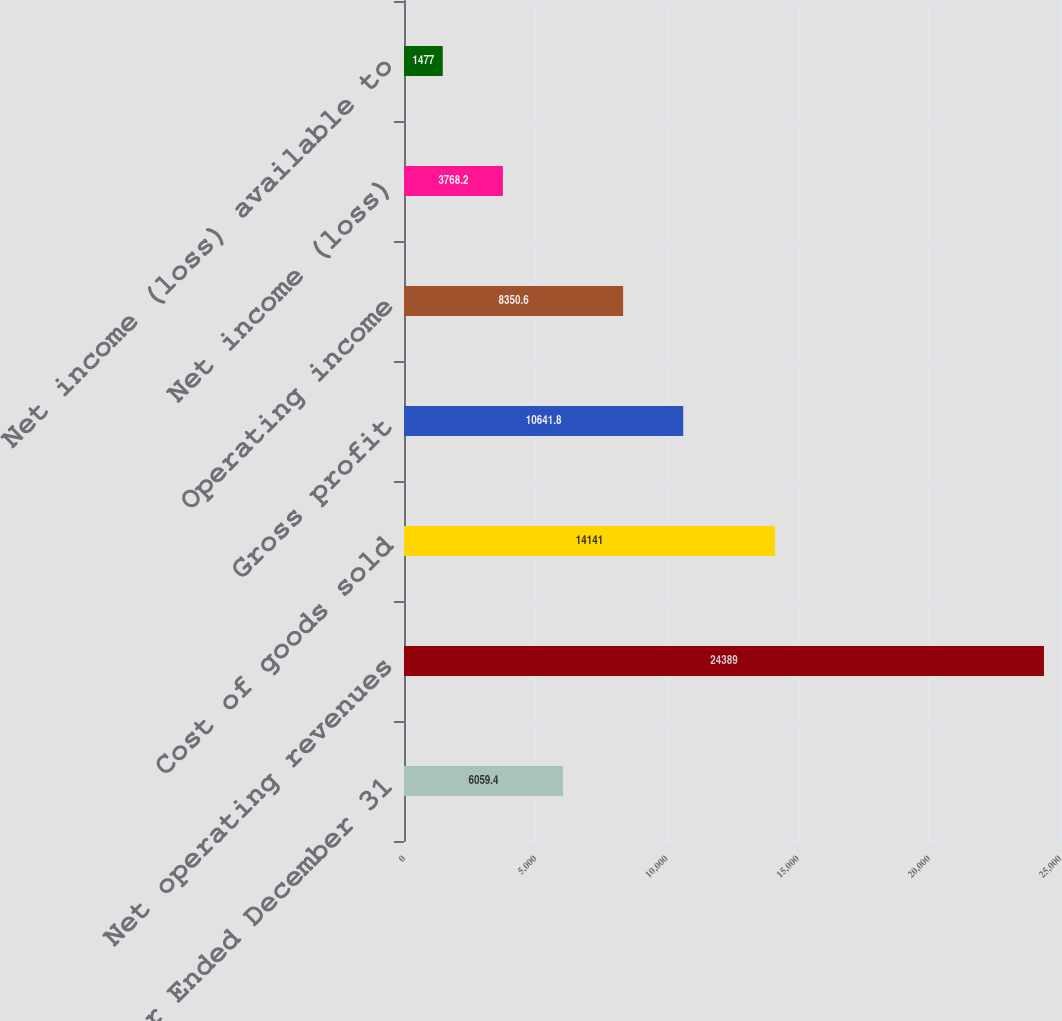<chart> <loc_0><loc_0><loc_500><loc_500><bar_chart><fcel>Year Ended December 31<fcel>Net operating revenues<fcel>Cost of goods sold<fcel>Gross profit<fcel>Operating income<fcel>Net income (loss)<fcel>Net income (loss) available to<nl><fcel>6059.4<fcel>24389<fcel>14141<fcel>10641.8<fcel>8350.6<fcel>3768.2<fcel>1477<nl></chart> 